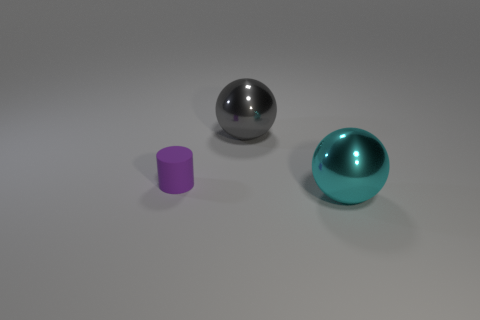Add 3 big spheres. How many objects exist? 6 Subtract all cylinders. How many objects are left? 2 Subtract all gray balls. Subtract all green cylinders. How many balls are left? 1 Subtract all yellow cylinders. How many gray balls are left? 1 Subtract all gray spheres. Subtract all tiny red rubber objects. How many objects are left? 2 Add 3 big metallic objects. How many big metallic objects are left? 5 Add 1 small purple matte cylinders. How many small purple matte cylinders exist? 2 Subtract 1 cyan spheres. How many objects are left? 2 